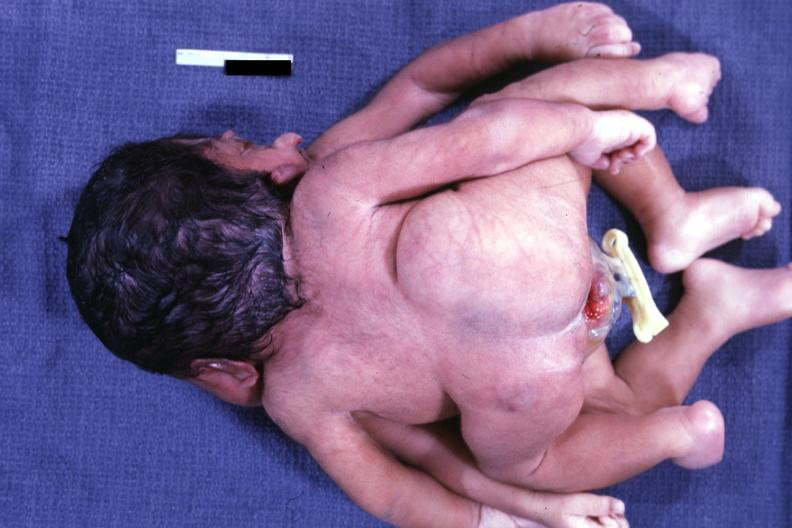what does this image show?
Answer the question using a single word or phrase. Posterior view 